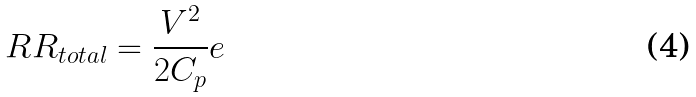Convert formula to latex. <formula><loc_0><loc_0><loc_500><loc_500>R R _ { t o t a l } = \frac { V ^ { 2 } } { 2 C _ { p } } e</formula> 